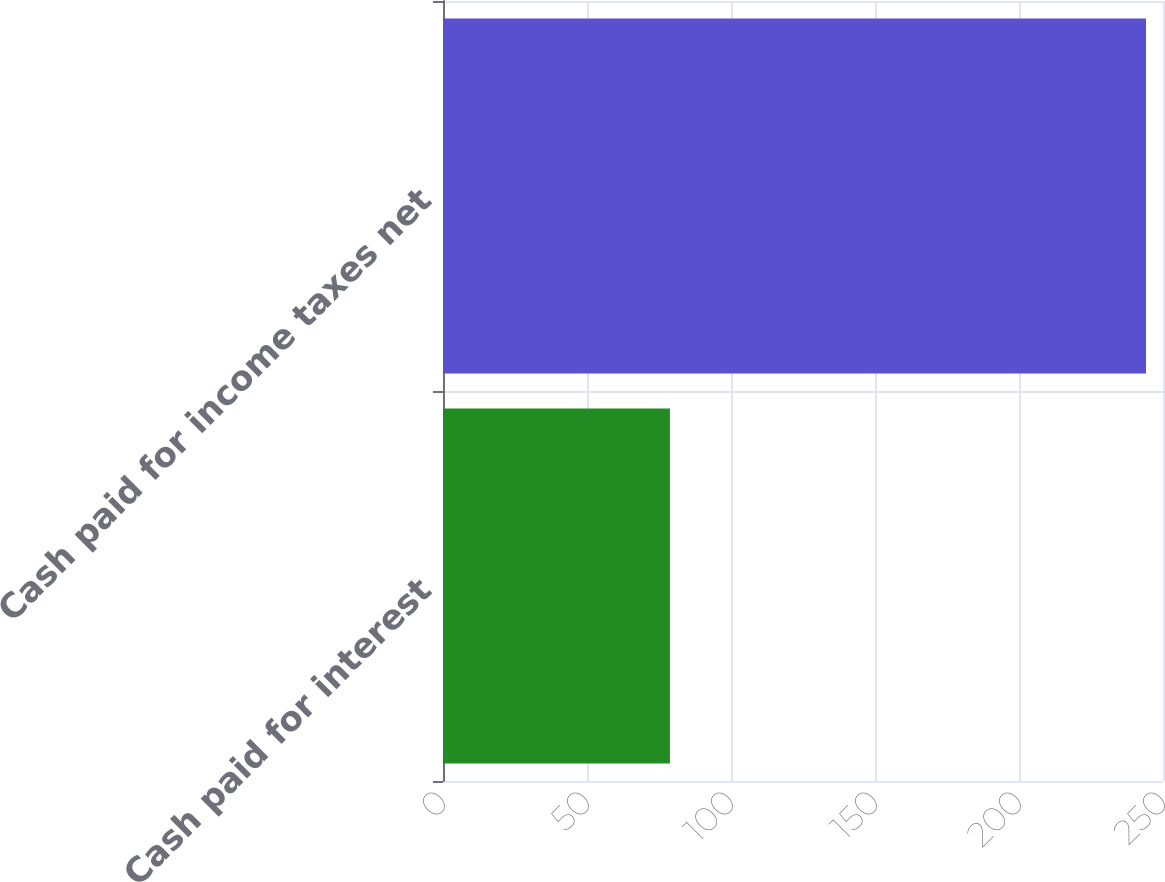Convert chart to OTSL. <chart><loc_0><loc_0><loc_500><loc_500><bar_chart><fcel>Cash paid for interest<fcel>Cash paid for income taxes net<nl><fcel>78.8<fcel>244.1<nl></chart> 